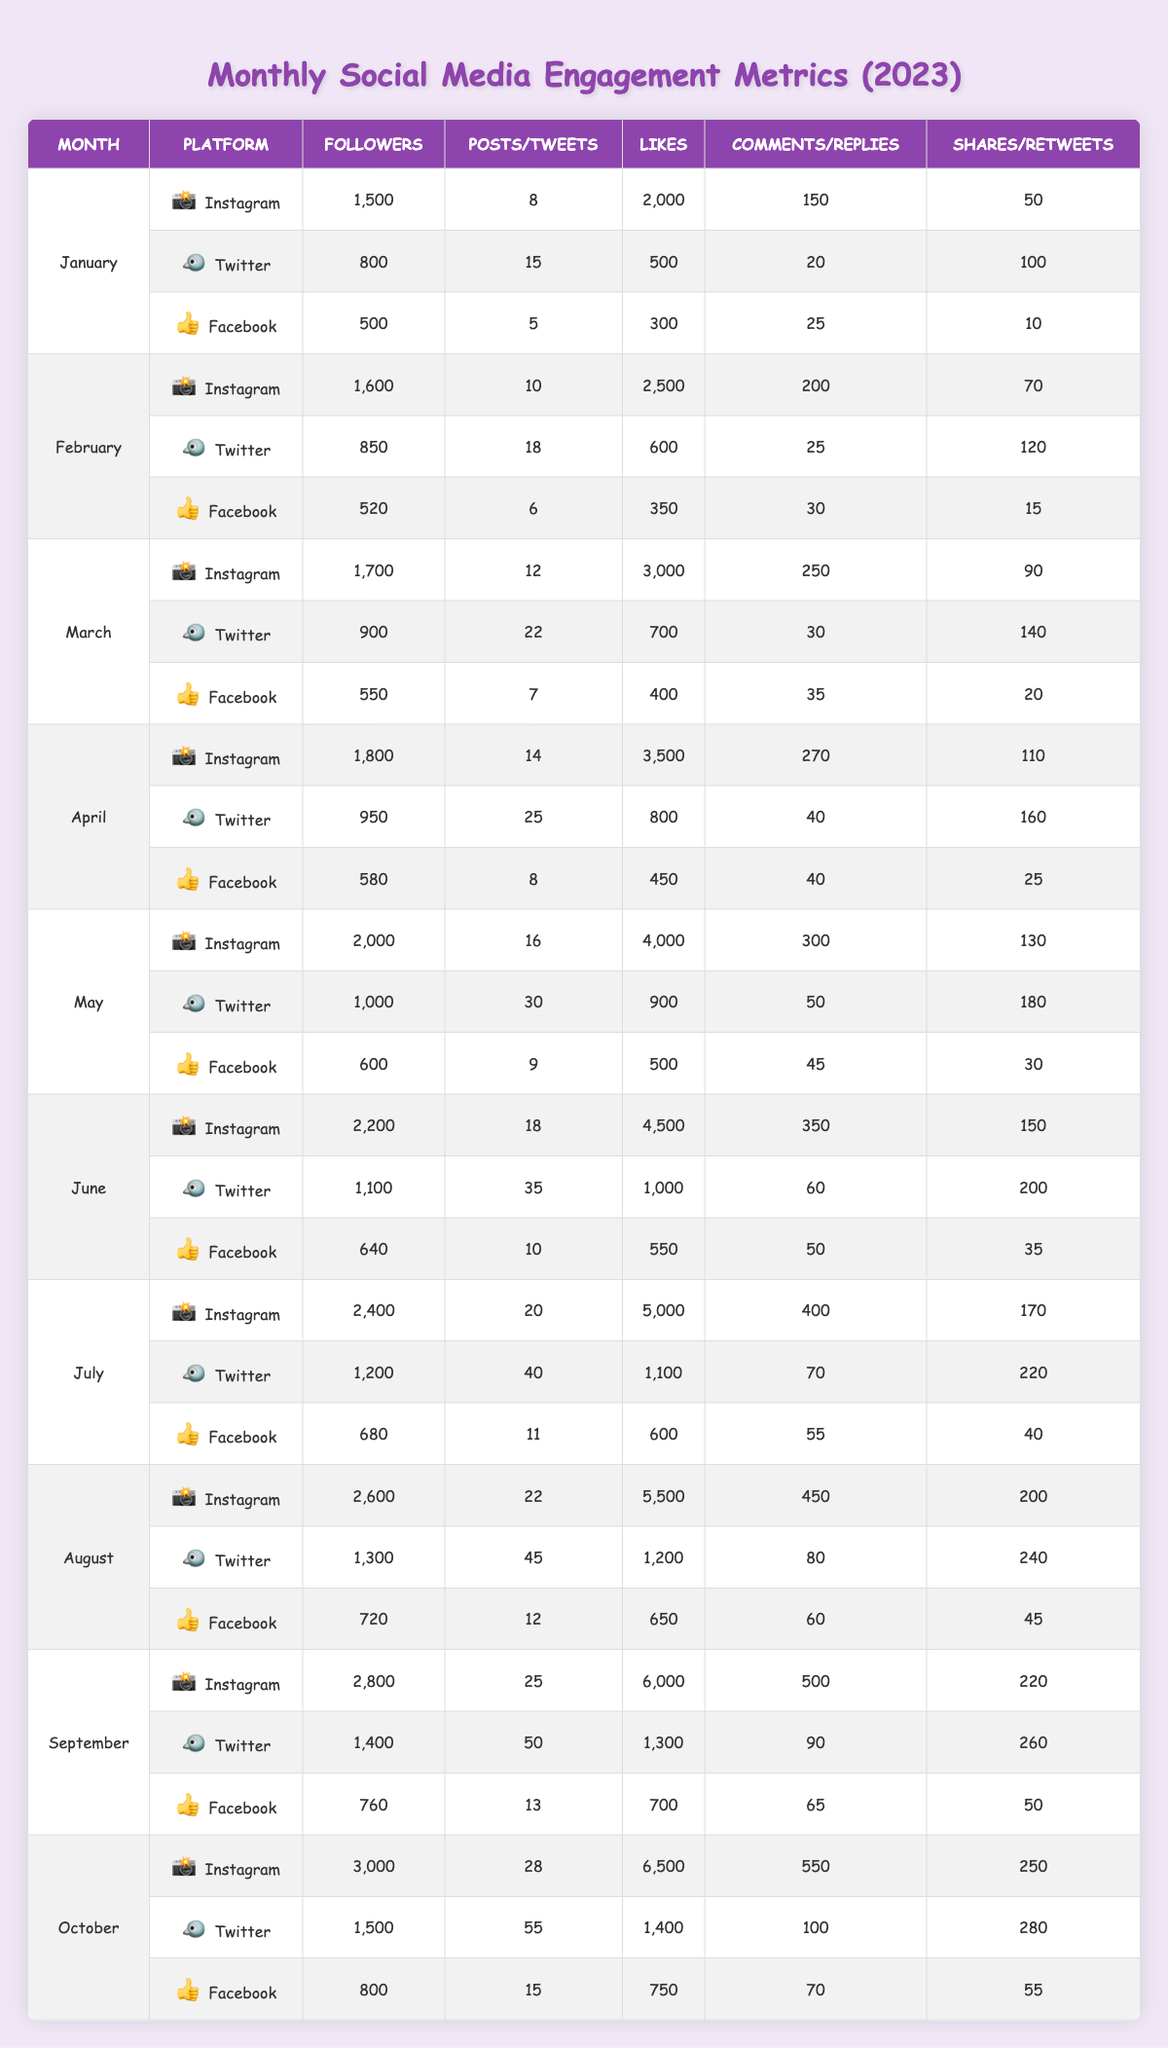What was the total number of likes on Instagram in June? In June, Instagram had 4,500 likes.
Answer: 4,500 How many followers did the artist gain from January to February on Twitter? In January, Twitter had 800 followers and in February, it had 850 followers, so the gain is 850 - 800 = 50 followers.
Answer: 50 What was the maximum number of shares on Facebook in October? In October, Facebook had 55 shares, which is the highest number when compared to previous months.
Answer: 55 Which platform had the most posts in July? In July, Instagram had 20 posts, Twitter had 40 tweets, and Facebook had 11 posts. The highest is Twitter with 40 tweets.
Answer: Twitter What is the average number of likes on Instagram from January to April? The likes for Instagram from January to April are 2,000, 2,500, 3,000, and 3,500. Their sum is 2,000 + 2,500 + 3,000 + 3,500 = 11,000, and the average is 11,000 / 4 = 2,750.
Answer: 2,750 In which month did Facebook have the least followers? The lowest number of followers for Facebook was 500 in January.
Answer: January Did the number of tweets on Twitter increase every month? The number of tweets for Twitter from January (15) to April (25) consistently increased. In May it had 30, June it had 35, and July it had 40, showing an increase every month.
Answer: Yes What was the total engagement (likes + comments + shares) on Instagram in August? In August, Instagram had 5,500 likes, 450 comments, and 200 shares. The total engagement equals 5,500 + 450 + 200 = 6,150.
Answer: 6,150 Was there a month where the artist had over 1,000 likes on Facebook? In every month from January to October, Facebook had over 1,000 likes, with October showing 750, which is below 1,000.
Answer: No What was the percentage increase in followers on Instagram from January to October? In January, Instagram had 1,500 followers and in October it had 3,000 followers. The increase is (3,000 - 1,500) = 1,500. The percentage increase is (1,500 / 1,500) * 100 = 100%.
Answer: 100% 